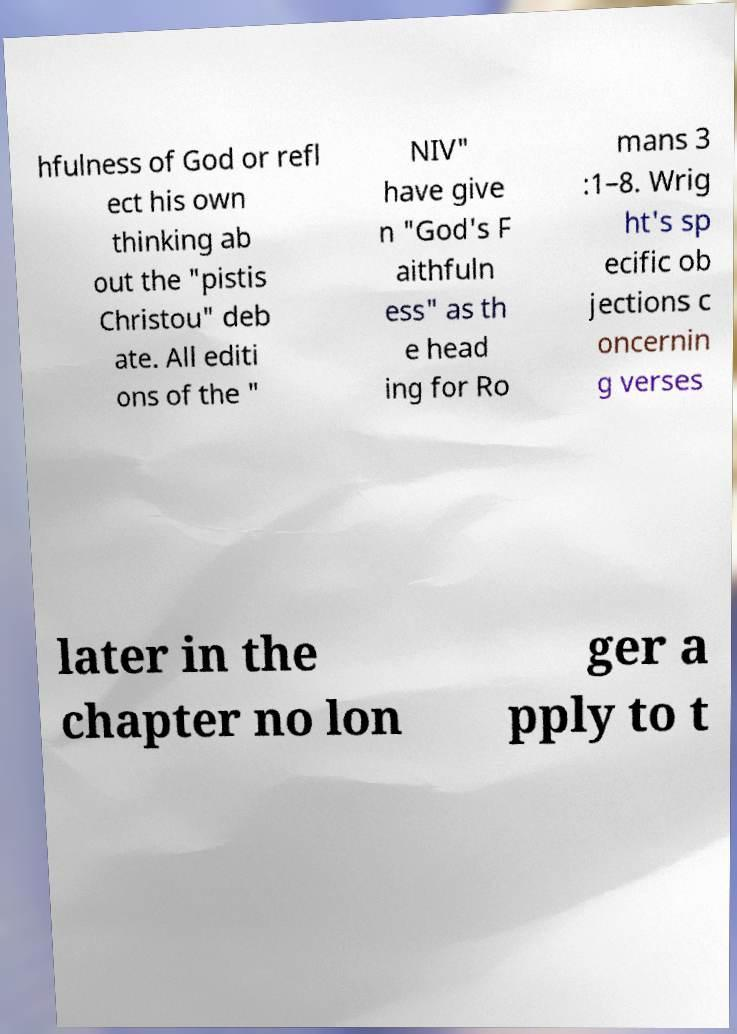Please read and relay the text visible in this image. What does it say? hfulness of God or refl ect his own thinking ab out the "pistis Christou" deb ate. All editi ons of the " NIV" have give n "God's F aithfuln ess" as th e head ing for Ro mans 3 :1–8. Wrig ht's sp ecific ob jections c oncernin g verses later in the chapter no lon ger a pply to t 